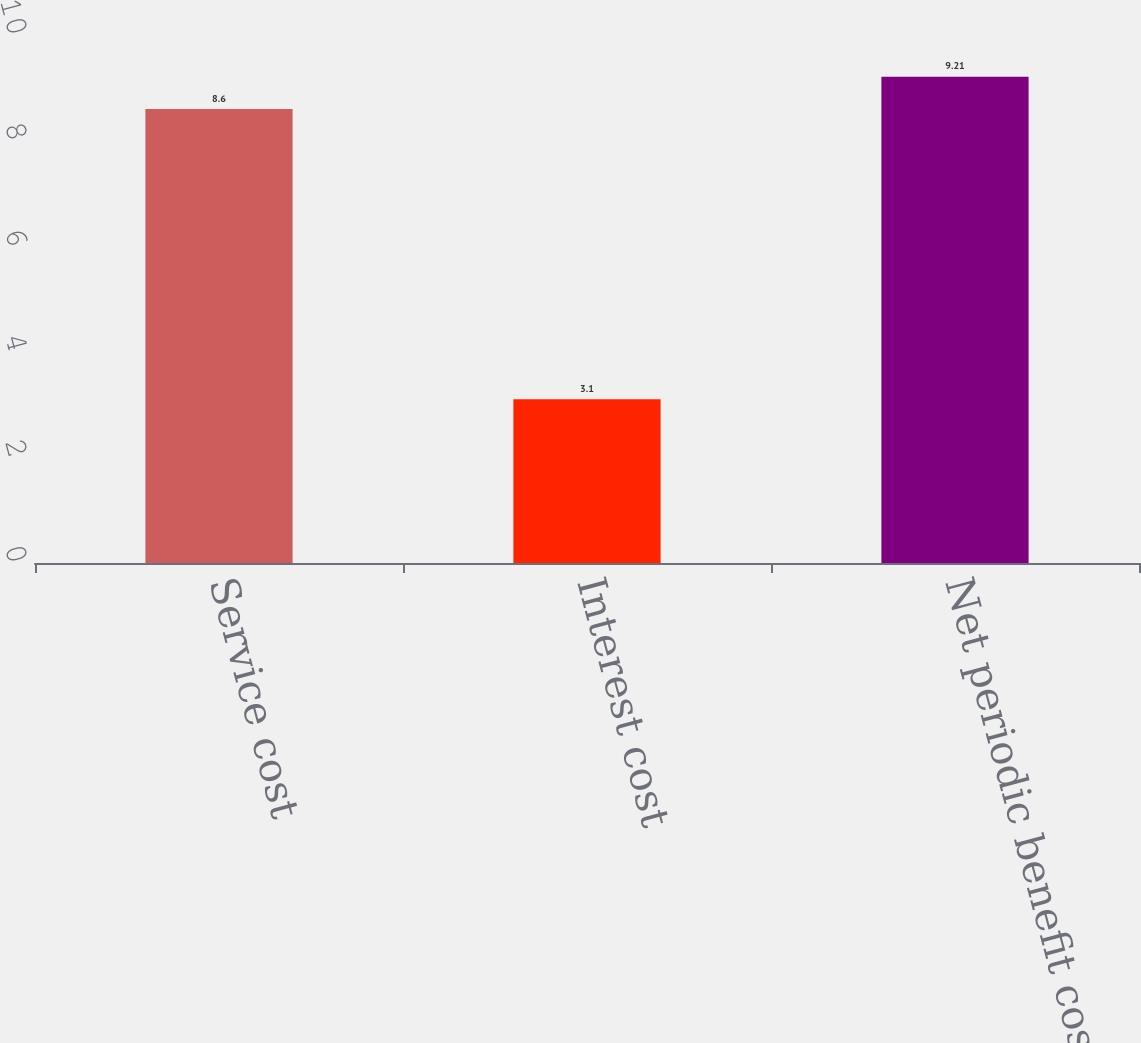<chart> <loc_0><loc_0><loc_500><loc_500><bar_chart><fcel>Service cost<fcel>Interest cost<fcel>Net periodic benefit cost<nl><fcel>8.6<fcel>3.1<fcel>9.21<nl></chart> 